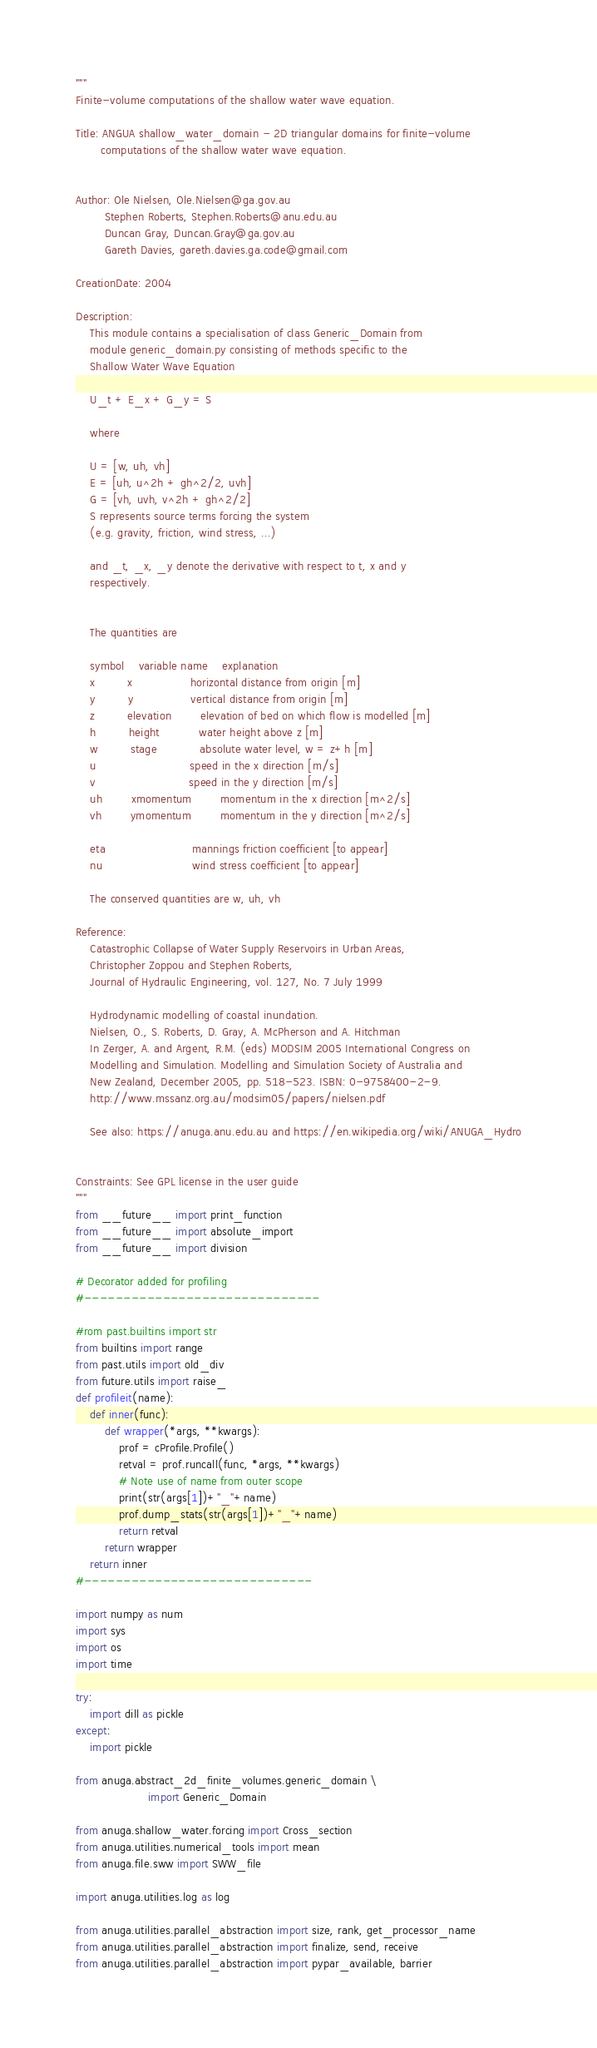Convert code to text. <code><loc_0><loc_0><loc_500><loc_500><_Python_>"""
Finite-volume computations of the shallow water wave equation.

Title: ANGUA shallow_water_domain - 2D triangular domains for finite-volume
       computations of the shallow water wave equation.


Author: Ole Nielsen, Ole.Nielsen@ga.gov.au
        Stephen Roberts, Stephen.Roberts@anu.edu.au
        Duncan Gray, Duncan.Gray@ga.gov.au
        Gareth Davies, gareth.davies.ga.code@gmail.com

CreationDate: 2004

Description:
    This module contains a specialisation of class Generic_Domain from
    module generic_domain.py consisting of methods specific to the
    Shallow Water Wave Equation

    U_t + E_x + G_y = S

    where

    U = [w, uh, vh]
    E = [uh, u^2h + gh^2/2, uvh]
    G = [vh, uvh, v^2h + gh^2/2]
    S represents source terms forcing the system
    (e.g. gravity, friction, wind stress, ...)

    and _t, _x, _y denote the derivative with respect to t, x and y
    respectively.


    The quantities are

    symbol    variable name    explanation
    x         x                horizontal distance from origin [m]
    y         y                vertical distance from origin [m]
    z         elevation        elevation of bed on which flow is modelled [m]
    h         height           water height above z [m]
    w         stage            absolute water level, w = z+h [m]
    u                          speed in the x direction [m/s]
    v                          speed in the y direction [m/s]
    uh        xmomentum        momentum in the x direction [m^2/s]
    vh        ymomentum        momentum in the y direction [m^2/s]

    eta                        mannings friction coefficient [to appear]
    nu                         wind stress coefficient [to appear]

    The conserved quantities are w, uh, vh

Reference:
    Catastrophic Collapse of Water Supply Reservoirs in Urban Areas,
    Christopher Zoppou and Stephen Roberts,
    Journal of Hydraulic Engineering, vol. 127, No. 7 July 1999

    Hydrodynamic modelling of coastal inundation.
    Nielsen, O., S. Roberts, D. Gray, A. McPherson and A. Hitchman
    In Zerger, A. and Argent, R.M. (eds) MODSIM 2005 International Congress on
    Modelling and Simulation. Modelling and Simulation Society of Australia and
    New Zealand, December 2005, pp. 518-523. ISBN: 0-9758400-2-9.
    http://www.mssanz.org.au/modsim05/papers/nielsen.pdf

    See also: https://anuga.anu.edu.au and https://en.wikipedia.org/wiki/ANUGA_Hydro


Constraints: See GPL license in the user guide
"""
from __future__ import print_function
from __future__ import absolute_import
from __future__ import division

# Decorator added for profiling
#------------------------------

#rom past.builtins import str
from builtins import range
from past.utils import old_div
from future.utils import raise_
def profileit(name):
    def inner(func):
        def wrapper(*args, **kwargs):
            prof = cProfile.Profile()
            retval = prof.runcall(func, *args, **kwargs)
            # Note use of name from outer scope
            print(str(args[1])+"_"+name)
            prof.dump_stats(str(args[1])+"_"+name)
            return retval
        return wrapper
    return inner
#-----------------------------

import numpy as num
import sys
import os
import time

try:
    import dill as pickle
except:
    import pickle

from anuga.abstract_2d_finite_volumes.generic_domain \
                    import Generic_Domain

from anuga.shallow_water.forcing import Cross_section
from anuga.utilities.numerical_tools import mean
from anuga.file.sww import SWW_file

import anuga.utilities.log as log

from anuga.utilities.parallel_abstraction import size, rank, get_processor_name
from anuga.utilities.parallel_abstraction import finalize, send, receive
from anuga.utilities.parallel_abstraction import pypar_available, barrier

</code> 